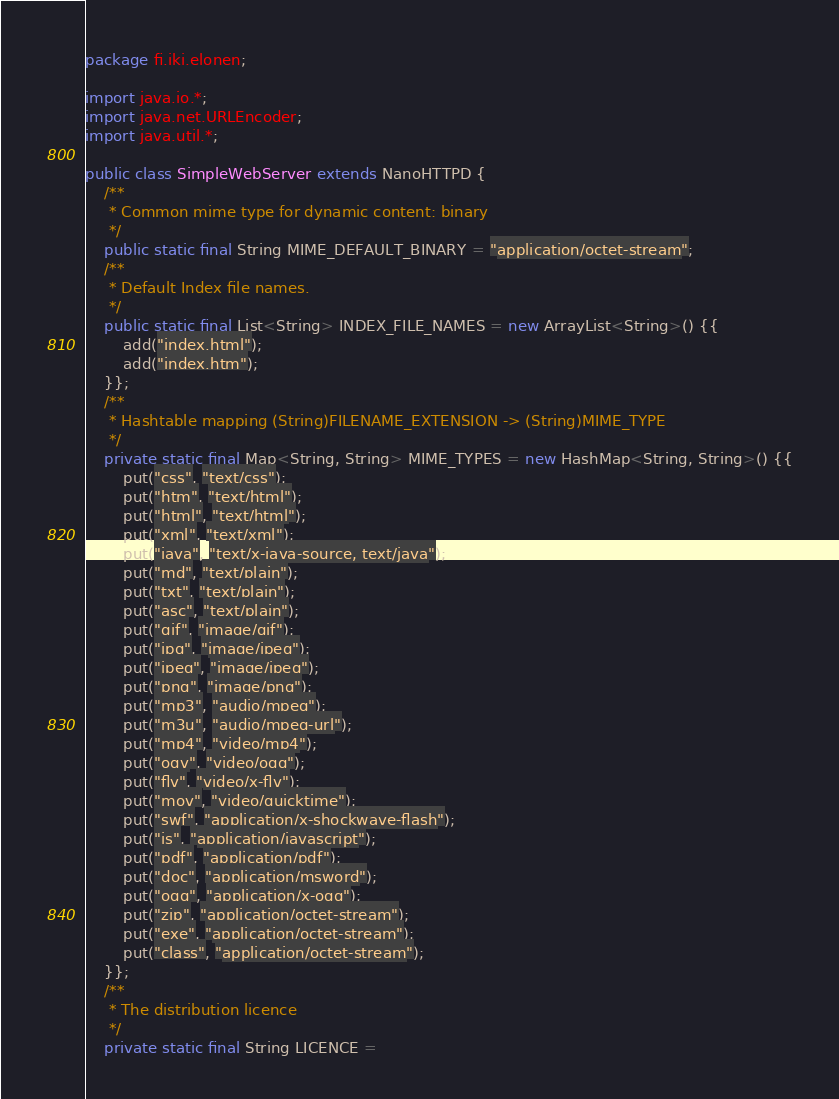Convert code to text. <code><loc_0><loc_0><loc_500><loc_500><_Java_>package fi.iki.elonen;

import java.io.*;
import java.net.URLEncoder;
import java.util.*;

public class SimpleWebServer extends NanoHTTPD {
    /**
     * Common mime type for dynamic content: binary
     */
    public static final String MIME_DEFAULT_BINARY = "application/octet-stream";
    /**
     * Default Index file names.
     */
    public static final List<String> INDEX_FILE_NAMES = new ArrayList<String>() {{
        add("index.html");
        add("index.htm");
    }};
    /**
     * Hashtable mapping (String)FILENAME_EXTENSION -> (String)MIME_TYPE
     */
    private static final Map<String, String> MIME_TYPES = new HashMap<String, String>() {{
        put("css", "text/css");
        put("htm", "text/html");
        put("html", "text/html");
        put("xml", "text/xml");
        put("java", "text/x-java-source, text/java");
        put("md", "text/plain");
        put("txt", "text/plain");
        put("asc", "text/plain");
        put("gif", "image/gif");
        put("jpg", "image/jpeg");
        put("jpeg", "image/jpeg");
        put("png", "image/png");
        put("mp3", "audio/mpeg");
        put("m3u", "audio/mpeg-url");
        put("mp4", "video/mp4");
        put("ogv", "video/ogg");
        put("flv", "video/x-flv");
        put("mov", "video/quicktime");
        put("swf", "application/x-shockwave-flash");
        put("js", "application/javascript");
        put("pdf", "application/pdf");
        put("doc", "application/msword");
        put("ogg", "application/x-ogg");
        put("zip", "application/octet-stream");
        put("exe", "application/octet-stream");
        put("class", "application/octet-stream");
    }};
    /**
     * The distribution licence
     */
    private static final String LICENCE =</code> 